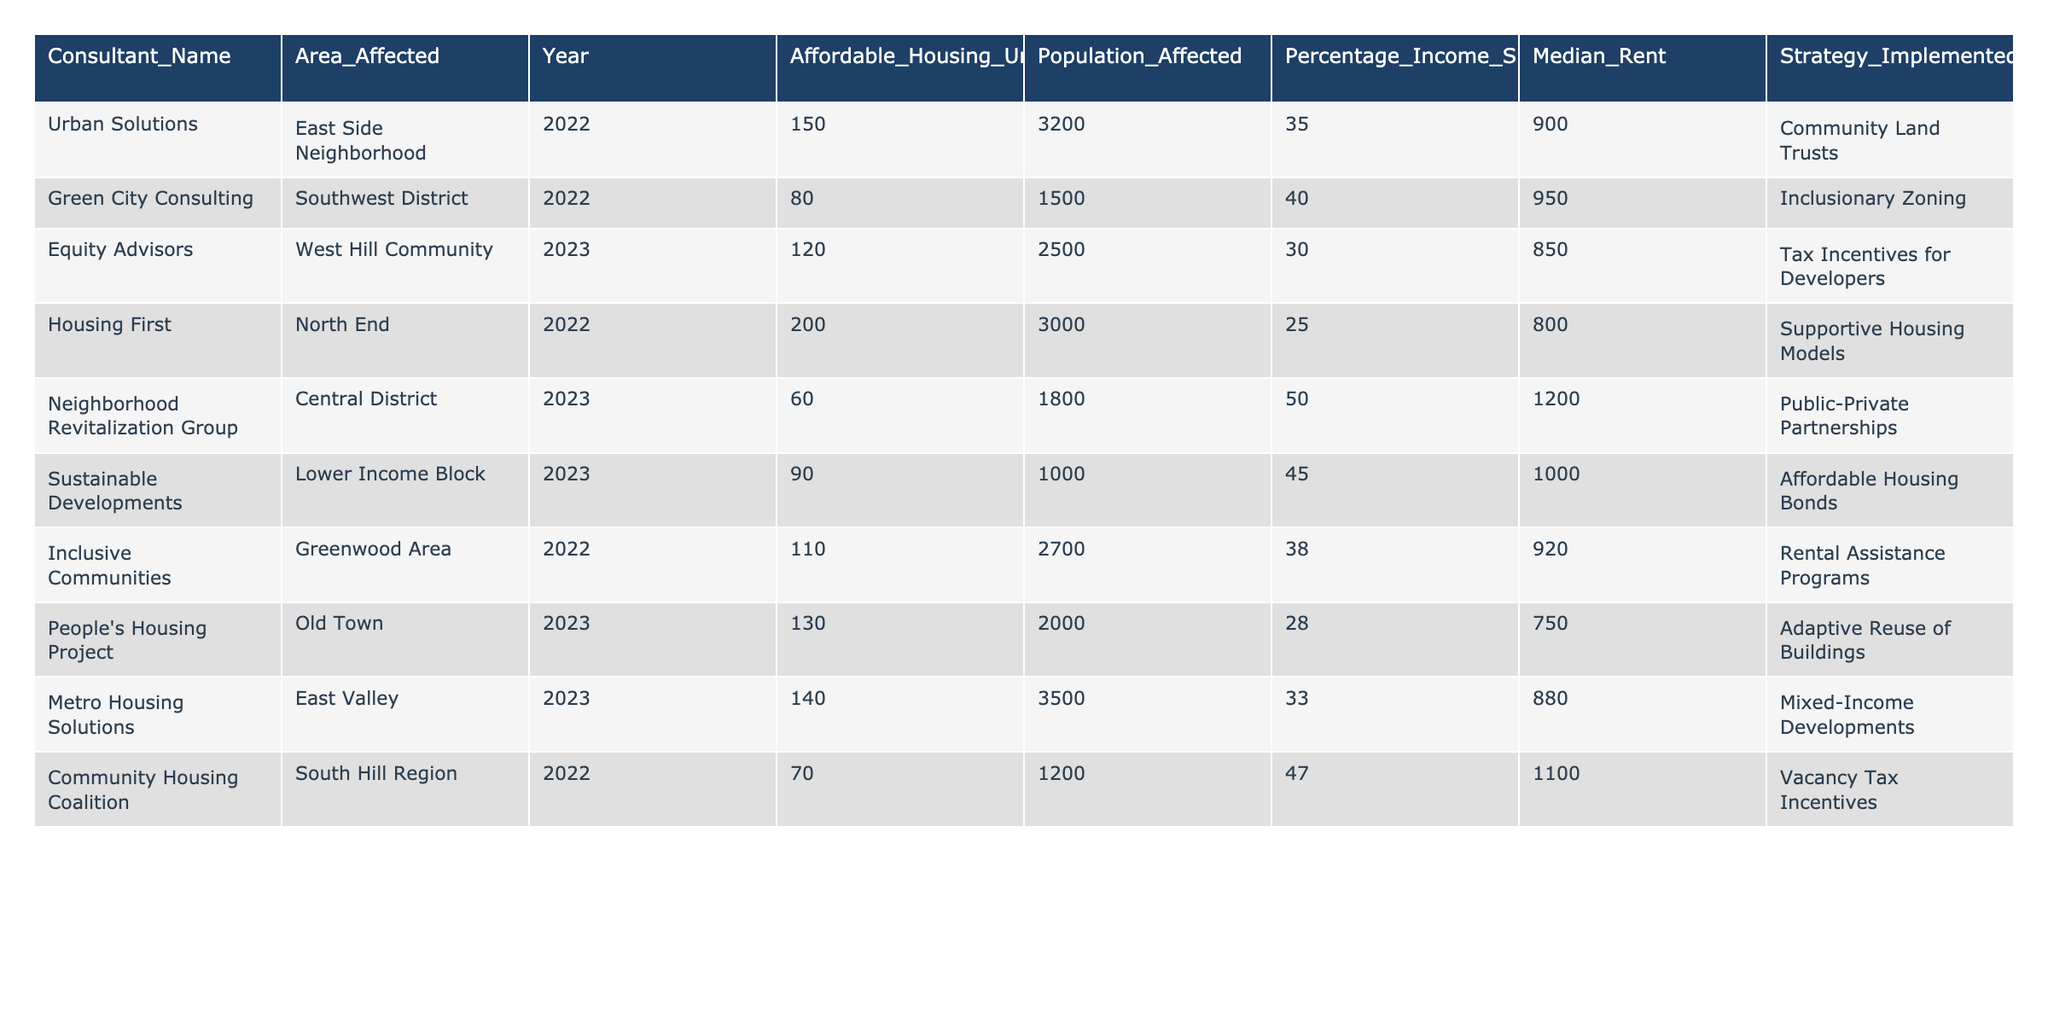What is the total number of affordable housing units available across all areas affected? To find the total number of affordable housing units available, I’ll sum the values from the "Affordable_Housing_Units_Available" column: 150 + 80 + 120 + 200 + 60 + 90 + 110 + 130 + 140 + 70 = 1,150
Answer: 1150 Which consultant implemented the most affordable housing units in 2023? In 2023, the consultants listed are Equity Advisors (120 units), Housing First (200 units), People's Housing Project (130 units), Metro Housing Solutions (140 units), and Neighborhood Revitalization Group (60 units). The highest is Housing First with 200 units.
Answer: Housing First What percentage of income is spent on housing in the Central District? Referring to the table, the Central District shows a "Percentage_Income_Spent_on_Housing" of 50%.
Answer: 50% Are there any areas where the percentage of income spent on housing exceeds 45%? The areas that exceed 45% are the Southwest District (40%) and the South Hill Region (47%). The South Hill Region does exceed 45%.
Answer: Yes What was the median rent in the West Hill Community? In the table, the "Median_Rent" for the West Hill Community is listed as 850.
Answer: 850 Which area has the highest percentage of income spent on housing, and what is that percentage? The area with the highest "Percentage_Income_Spent_on_Housing" is the Central District at 50%.
Answer: Central District, 50% If we average the median rents for all areas listed, what is the average rent? Adding the median rents: 900 + 950 + 850 + 800 + 1200 + 1000 + 920 + 750 + 880 + 1100 = 10,450, and dividing by 10 gives an average rent of 1,045.
Answer: 1045 Which area saw an increase in affordable housing units available from 2022 to 2023? By comparing the "Affordable_Housing_Units_Available" for 2022 and 2023, the following showed an increase: West Hill Community (120 in 2023).
Answer: West Hill Community Which housing strategy was used in the area with the most affordable housing units available? The area with the most units is North End, which followed the "Supportive Housing Models" strategy.
Answer: Supportive Housing Models What is the difference in affordable housing units available between the East Side Neighborhood and the South West District? The East Side Neighborhood has 150 units and the South West District has 80 units. The difference is 150 - 80 = 70 units.
Answer: 70 